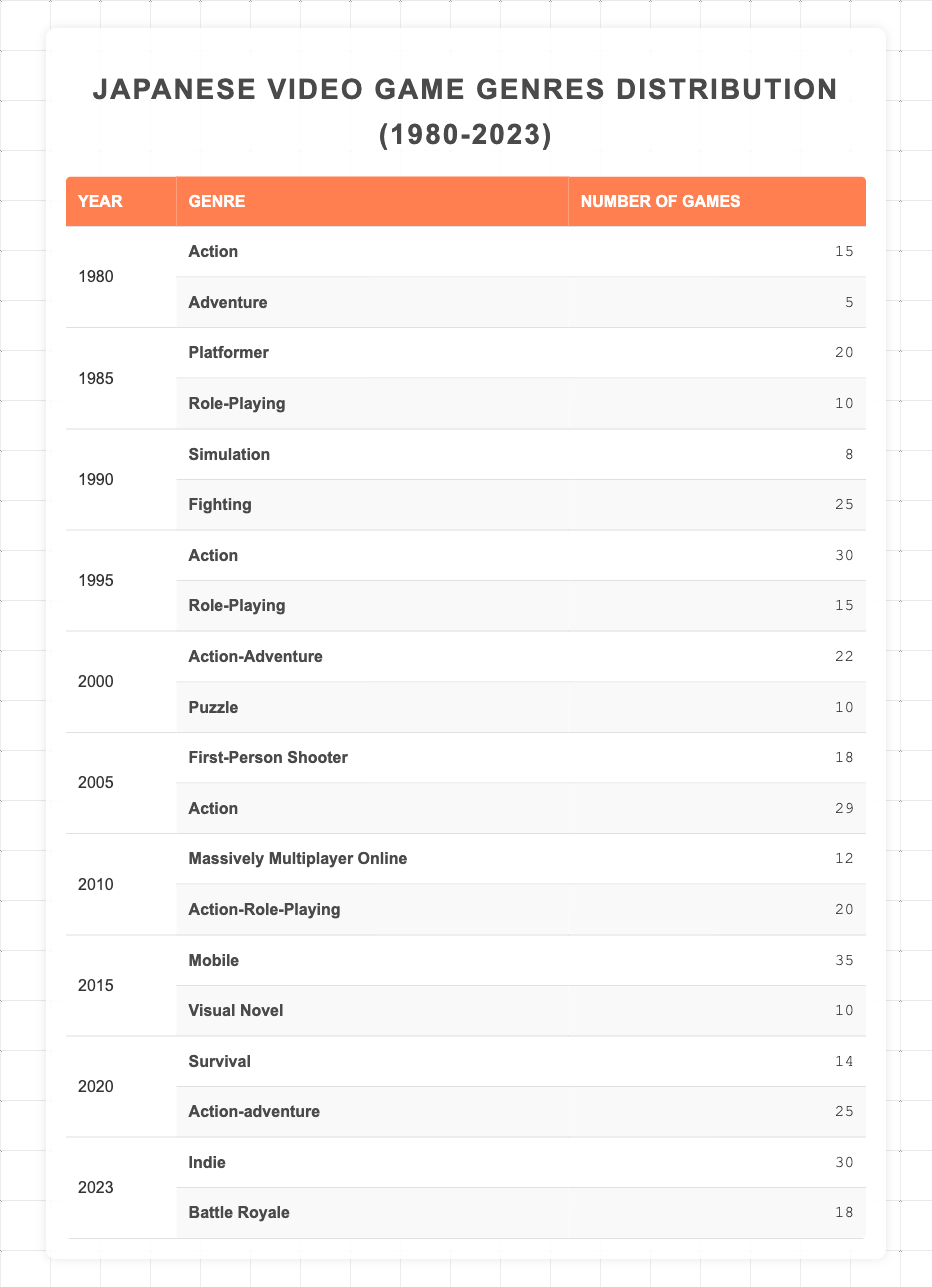What was the genre with the most games released in 2015? The table shows that in 2015, the "Mobile" genre had 35 games released, which is more than any other genre that year.
Answer: Mobile How many action games were released in 1995? In 1995, the table lists "Action" with 30 games, which is the total number of action games released that year.
Answer: 30 Which year had the least number of role-playing games released? By checking the table, the year with the least number of role-playing games is 1985, with only 10 games released.
Answer: 1985 What is the total number of survival and action-adventure games released in 2020? From the table, "Survival" had 14 games and "Action-adventure" had 25 games. Adding these gives a total of 14 + 25 = 39 games.
Answer: 39 True or false: The number of games in the "Platformer" genre exceeded 25 in any year between 1980 and 2023. Checking the table, the highest number for "Platformer" was 20 games in 1985, which is less than 25, thus the statement is false.
Answer: False In which year were there more fighting games than simulation games? The table indicates that in 1990, there were 25 fighting games and only 8 simulation games. Therefore, 1990 is the answer as it is the only year with this condition.
Answer: 1990 What is the average number of games per year for the "Indie" genre from 2020 to 2023? In 2023, "Indie" had 30 games. The average over two years from 2020 to 2023 (indie games only specified in 2023) equals 30/1 = 30 games. For the full period including 2020 to 2022, there were no indie releases listed.
Answer: 30 How many more action games were released in 2005 compared to 1980? The table shows 29 action games in 2005 and 15 in 1980. The difference is 29 - 15 = 14 more action games in 2005 than in 1980.
Answer: 14 What was the total number of games released in the "Adventure" genre from 1980 to 2023? Referring to the table, "Adventure" games totaled 5 in 1980 and had no further entries in subsequent years, resulting in a total of 5 games.
Answer: 5 